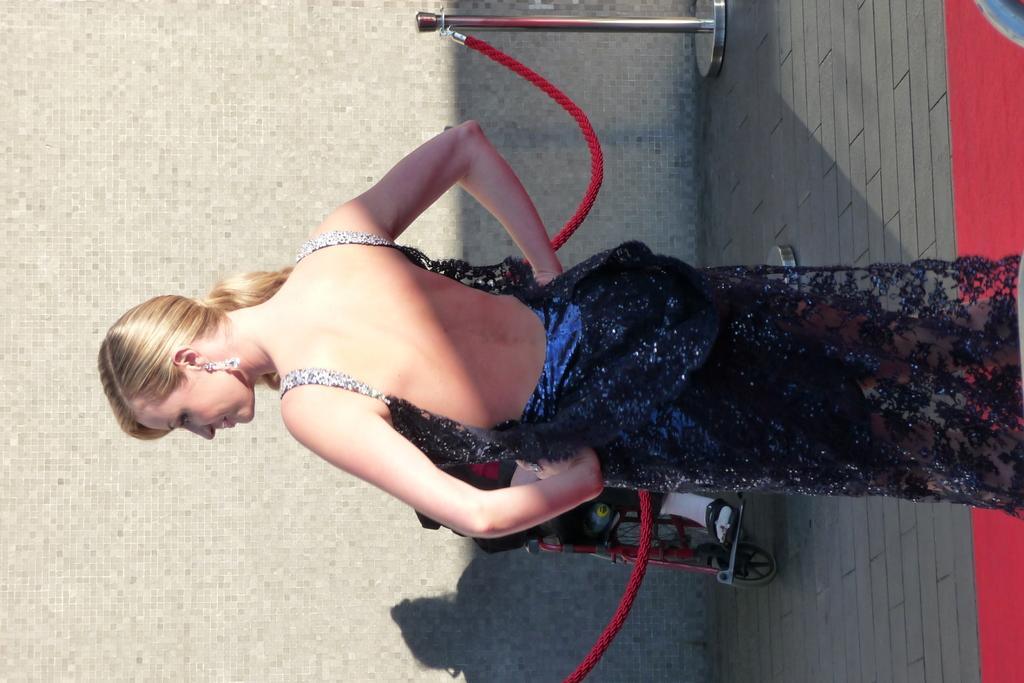Can you describe this image briefly? In this picture we can see a woman standing on a red carpet. There are few ropes and stands. 